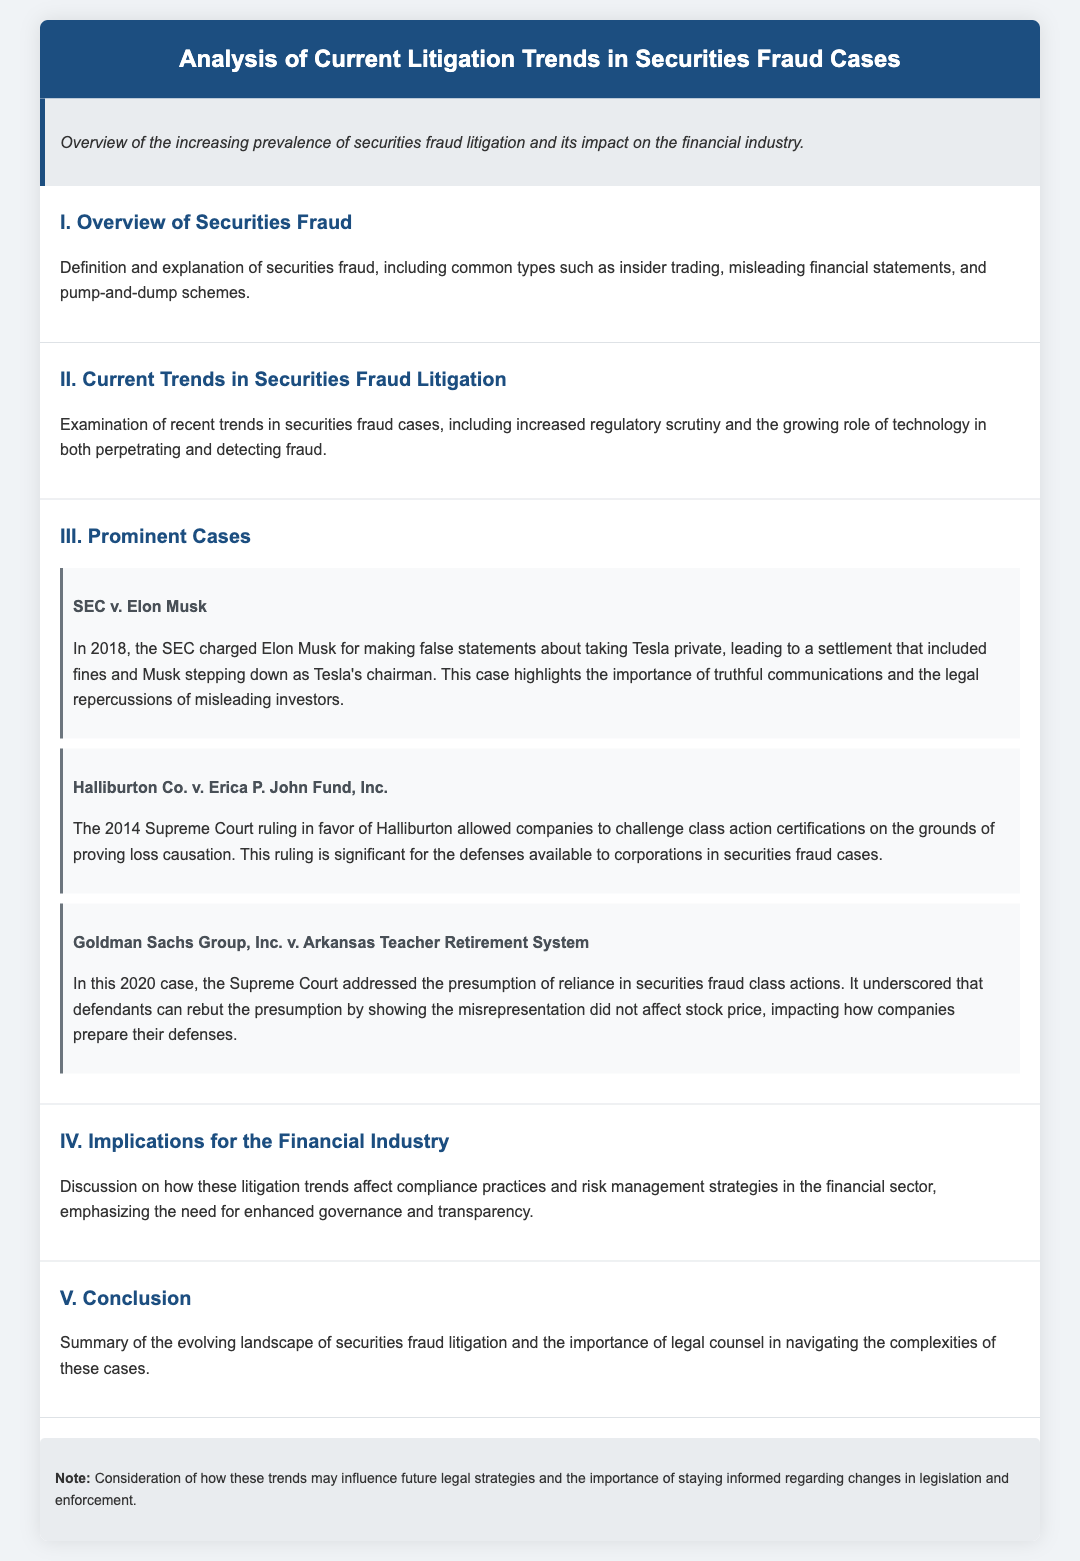What is the title of the document? The title of the document is stated in the header section, "Analysis of Current Litigation Trends in Securities Fraud Cases."
Answer: Analysis of Current Litigation Trends in Securities Fraud Cases What year was the SEC v. Elon Musk case charged? The case date is mentioned as part of the case summary indicating it was charged in 2018.
Answer: 2018 What was the Supreme Court ruling related to Halliburton Co. case? It states that the Supreme Court ruling in 2014 allowed companies to challenge class action certifications based on loss causation.
Answer: Allowed companies to challenge class action certifications What does the 2020 Goldman Sachs case address? The document notes that the case addresses the presumption of reliance in securities fraud class actions.
Answer: Presumption of reliance What type of fraud is described as “pump-and-dump” in the document? This phrase is categorized as one of the common types of securities fraud mentioned.
Answer: Pump-and-dump How does the document categorize the overview section? The overview section explains the definition and common types of securities fraud.
Answer: Definition and explanation of securities fraud What is a key implication for the financial industry discussed? The document emphasizes the need for enhanced governance and transparency in compliance practices.
Answer: Enhanced governance and transparency What is a significant outcome mentioned regarding the SEC v. Elon Musk? The outcome includes Musk stepping down as Tesla's chairman after the settlement.
Answer: Musk stepping down as Tesla's chairman What is a consequence of the Halliburton ruling for corporations? The ruling is significant for the defenses available to corporations in securities fraud cases.
Answer: Defenses available to corporations 